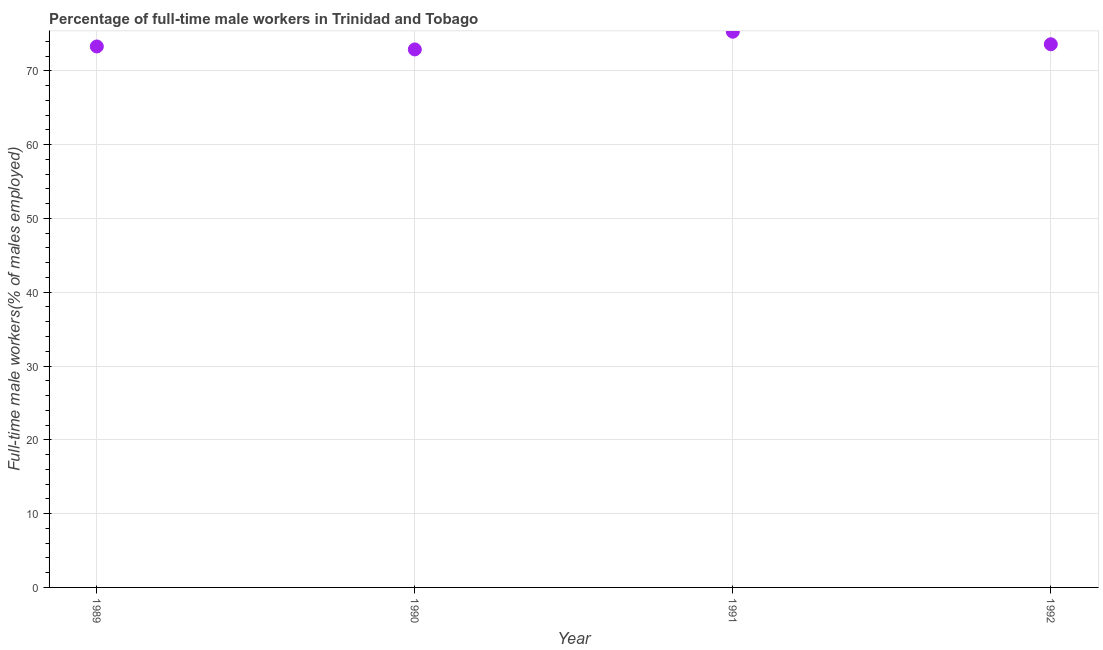What is the percentage of full-time male workers in 1990?
Your answer should be compact. 72.9. Across all years, what is the maximum percentage of full-time male workers?
Offer a terse response. 75.3. Across all years, what is the minimum percentage of full-time male workers?
Your response must be concise. 72.9. What is the sum of the percentage of full-time male workers?
Your response must be concise. 295.1. What is the difference between the percentage of full-time male workers in 1991 and 1992?
Your answer should be compact. 1.7. What is the average percentage of full-time male workers per year?
Provide a short and direct response. 73.78. What is the median percentage of full-time male workers?
Make the answer very short. 73.45. What is the ratio of the percentage of full-time male workers in 1991 to that in 1992?
Offer a terse response. 1.02. Is the percentage of full-time male workers in 1989 less than that in 1990?
Offer a very short reply. No. Is the difference between the percentage of full-time male workers in 1989 and 1992 greater than the difference between any two years?
Provide a short and direct response. No. What is the difference between the highest and the second highest percentage of full-time male workers?
Ensure brevity in your answer.  1.7. Is the sum of the percentage of full-time male workers in 1989 and 1990 greater than the maximum percentage of full-time male workers across all years?
Offer a terse response. Yes. What is the difference between the highest and the lowest percentage of full-time male workers?
Provide a short and direct response. 2.4. How many years are there in the graph?
Offer a very short reply. 4. Are the values on the major ticks of Y-axis written in scientific E-notation?
Your answer should be compact. No. Does the graph contain any zero values?
Keep it short and to the point. No. Does the graph contain grids?
Ensure brevity in your answer.  Yes. What is the title of the graph?
Provide a succinct answer. Percentage of full-time male workers in Trinidad and Tobago. What is the label or title of the X-axis?
Make the answer very short. Year. What is the label or title of the Y-axis?
Your answer should be very brief. Full-time male workers(% of males employed). What is the Full-time male workers(% of males employed) in 1989?
Make the answer very short. 73.3. What is the Full-time male workers(% of males employed) in 1990?
Offer a very short reply. 72.9. What is the Full-time male workers(% of males employed) in 1991?
Give a very brief answer. 75.3. What is the Full-time male workers(% of males employed) in 1992?
Make the answer very short. 73.6. What is the difference between the Full-time male workers(% of males employed) in 1989 and 1990?
Your response must be concise. 0.4. What is the difference between the Full-time male workers(% of males employed) in 1990 and 1991?
Provide a short and direct response. -2.4. What is the ratio of the Full-time male workers(% of males employed) in 1989 to that in 1991?
Offer a terse response. 0.97. What is the ratio of the Full-time male workers(% of males employed) in 1990 to that in 1992?
Provide a succinct answer. 0.99. 